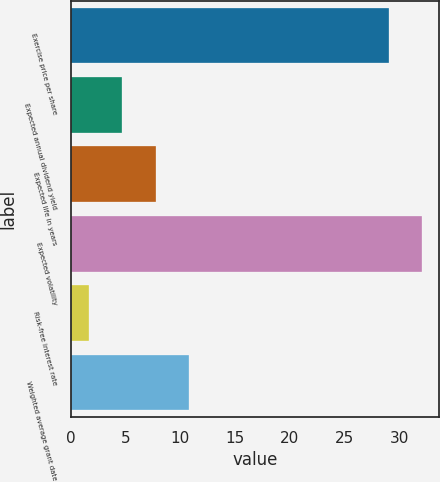<chart> <loc_0><loc_0><loc_500><loc_500><bar_chart><fcel>Exercise price per share<fcel>Expected annual dividend yield<fcel>Expected life in years<fcel>Expected volatility<fcel>Risk-free interest rate<fcel>Weighted average grant date<nl><fcel>29.06<fcel>4.73<fcel>7.76<fcel>32.09<fcel>1.7<fcel>10.79<nl></chart> 